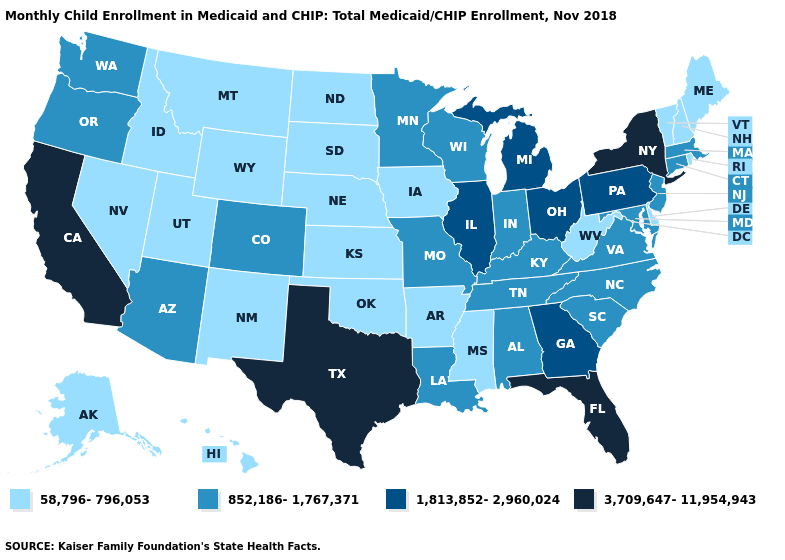Name the states that have a value in the range 3,709,647-11,954,943?
Be succinct. California, Florida, New York, Texas. Name the states that have a value in the range 852,186-1,767,371?
Write a very short answer. Alabama, Arizona, Colorado, Connecticut, Indiana, Kentucky, Louisiana, Maryland, Massachusetts, Minnesota, Missouri, New Jersey, North Carolina, Oregon, South Carolina, Tennessee, Virginia, Washington, Wisconsin. Among the states that border Utah , which have the lowest value?
Give a very brief answer. Idaho, Nevada, New Mexico, Wyoming. Is the legend a continuous bar?
Write a very short answer. No. What is the highest value in the MidWest ?
Short answer required. 1,813,852-2,960,024. What is the highest value in the MidWest ?
Write a very short answer. 1,813,852-2,960,024. Name the states that have a value in the range 1,813,852-2,960,024?
Be succinct. Georgia, Illinois, Michigan, Ohio, Pennsylvania. What is the value of Indiana?
Be succinct. 852,186-1,767,371. Among the states that border Virginia , does West Virginia have the lowest value?
Answer briefly. Yes. Name the states that have a value in the range 852,186-1,767,371?
Answer briefly. Alabama, Arizona, Colorado, Connecticut, Indiana, Kentucky, Louisiana, Maryland, Massachusetts, Minnesota, Missouri, New Jersey, North Carolina, Oregon, South Carolina, Tennessee, Virginia, Washington, Wisconsin. Does Texas have the highest value in the USA?
Quick response, please. Yes. What is the highest value in states that border Arizona?
Give a very brief answer. 3,709,647-11,954,943. Does Wisconsin have a higher value than Rhode Island?
Give a very brief answer. Yes. Among the states that border South Dakota , which have the highest value?
Short answer required. Minnesota. Among the states that border Mississippi , does Arkansas have the highest value?
Short answer required. No. 